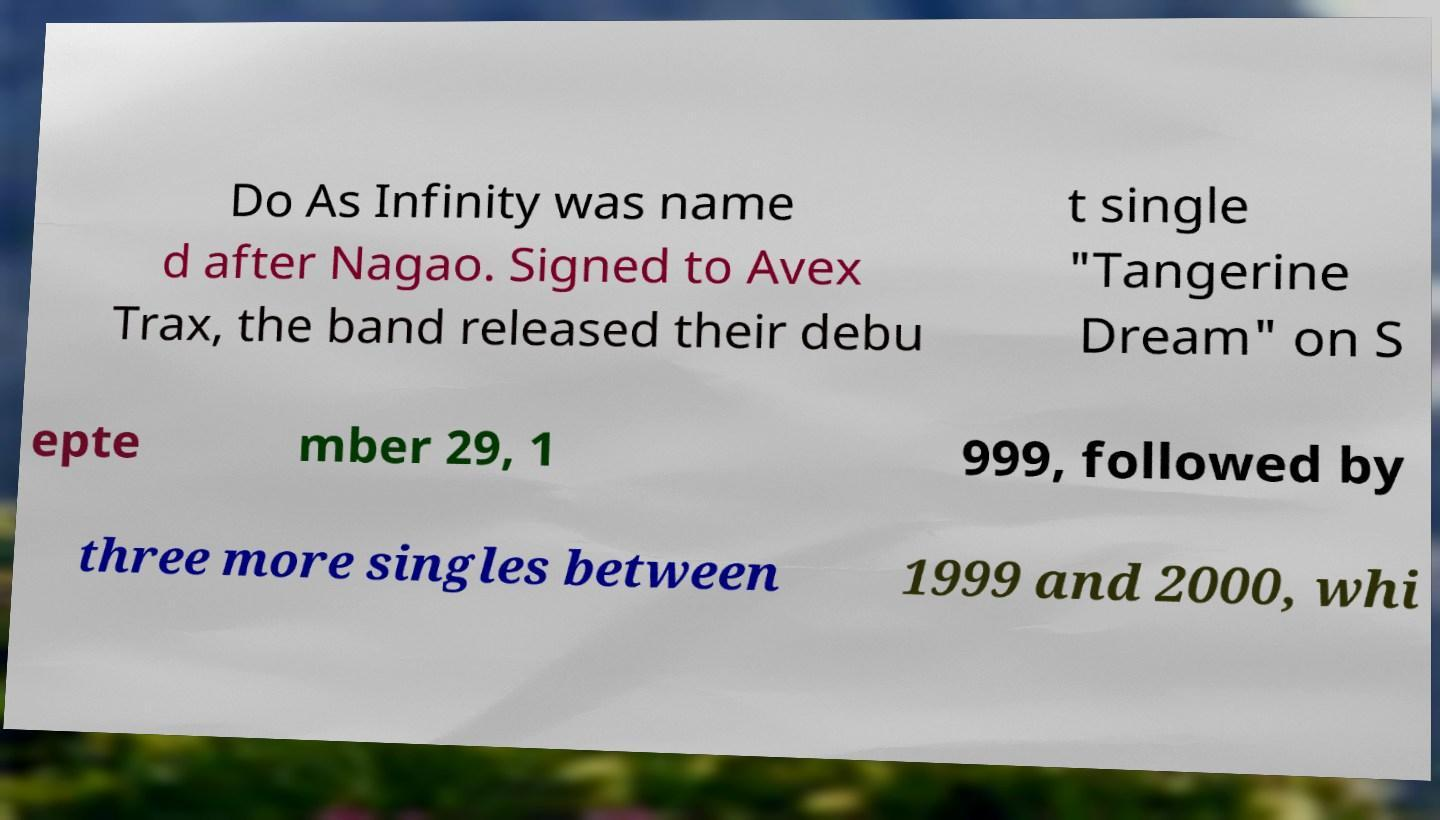Could you extract and type out the text from this image? Do As Infinity was name d after Nagao. Signed to Avex Trax, the band released their debu t single "Tangerine Dream" on S epte mber 29, 1 999, followed by three more singles between 1999 and 2000, whi 